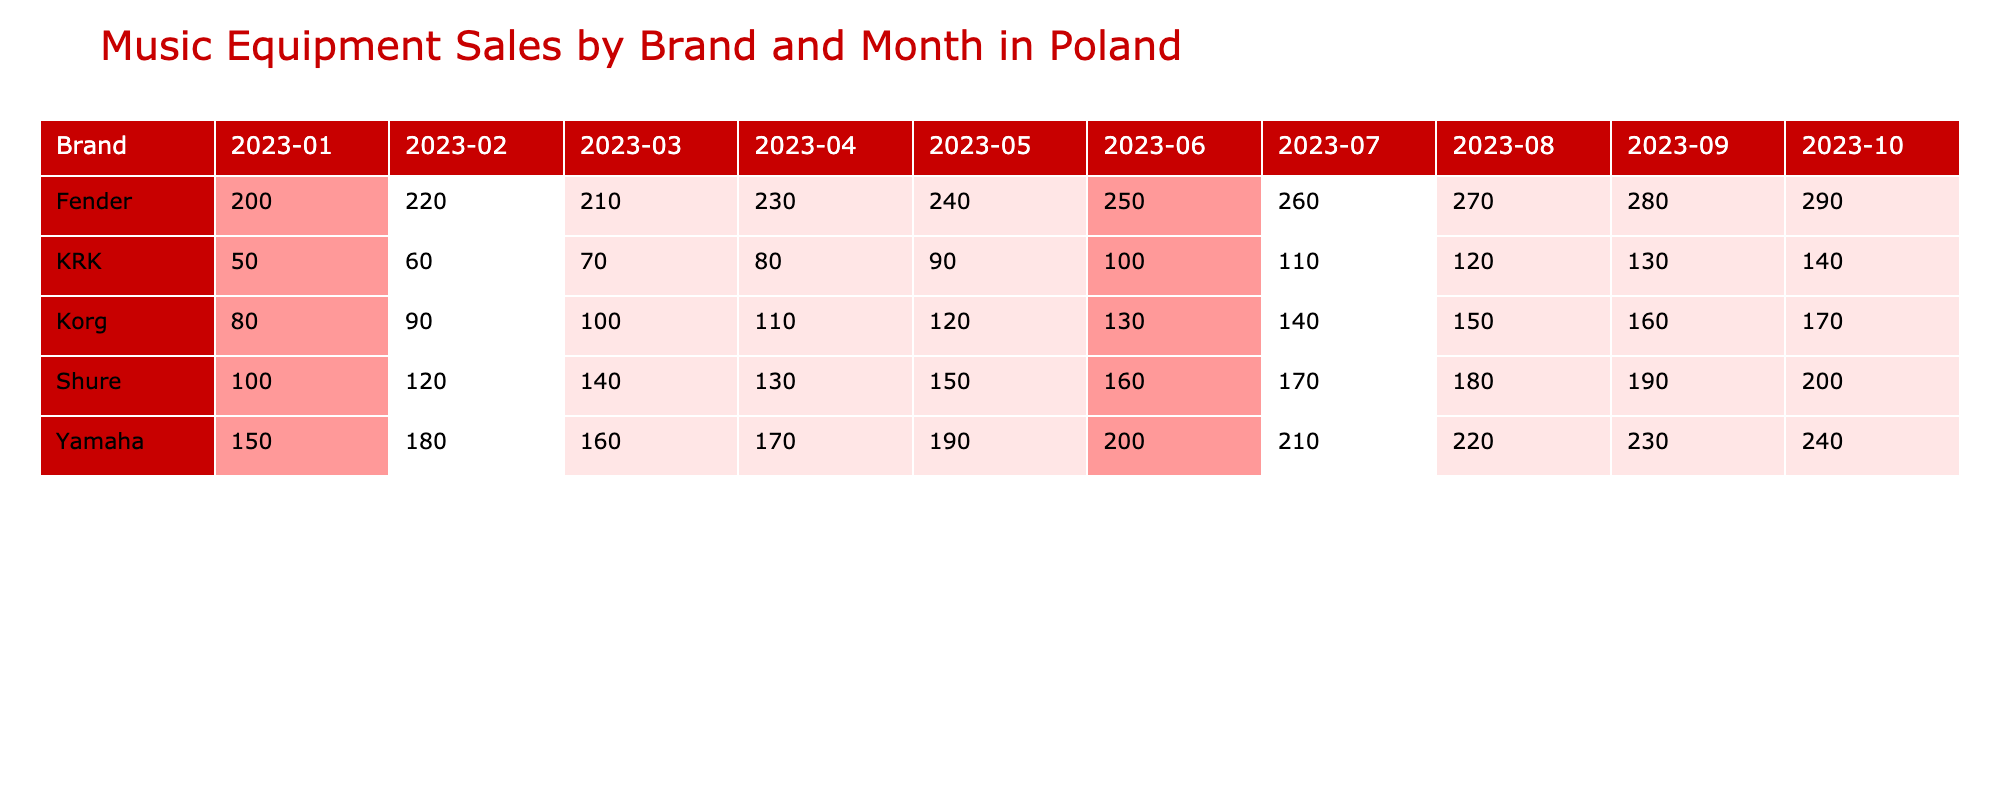What brand had the highest sales in June 2023? In June 2023, Yamaha, Fender, Shure, KRK, and Korg had sales of 200, 250, 160, 100, and 130 units respectively. Among these, Fender had the highest sales at 250 units.
Answer: Fender What were the total sales for Shure microphones from January to April 2023? The sales for Shure microphones from January to April are as follows: January - 100, February - 120, March - 140, April - 130. Adding these gives 100 + 120 + 140 + 130 = 490 units.
Answer: 490 units Did Korg synthesizers sell more in September 2023 than in August 2023? In August 2023, Korg sold 150 units and in September 2023, Korg sold 160 units. Since 160 is greater than 150, Korg sold more in September.
Answer: Yes What is the average monthly sales of guitars for Yamaha from January to October 2023? Adding the sales of Yamaha guitars from each month: 150 + 180 + 160 + 170 + 190 + 200 + 210 + 220 + 230 + 240 = 2000. This total is divided by the 10 months, yielding an average of 2000 / 10 = 200.
Answer: 200 Which brand had the lowest sales for monitors in March 2023? In March 2023, the sales for monitors were: KRK - 70 units. Since there is only one entry for monitors, KRK had the lowest sales.
Answer: KRK What was the difference in sales units between the best-selling and worst-selling brand for guitars in October 2023? In October 2023, Fender sold 290 guitars, while Yamaha sold 240 guitars. The difference is 290 - 240 = 50 units.
Answer: 50 units How did the sales of Fender guitars change over the months from January to October 2023? Fender guitars sold 200 in January, increasing each month to 290 in October, showing a steady upward trend with an increase of 90 units over 10 months.
Answer: Steadily increased Which brand consistently had increasing sales each month for synthesizers? Korg synthesizers had sales of 80 in January, increasing to 170 in October, showing a consistent increase each month.
Answer: Korg What was the total sales for KRK monitors from January to September 2023? The sales for KRK monitors were: January - 50, February - 60, March - 70, April - 80, May - 90, June - 100, July - 110, August - 120, September - 130. Adding these gives a total of 50 + 60 + 70 + 80 + 90 + 100 + 110 + 120 + 130 = 820.
Answer: 820 units Which month had the highest sales for guitars overall, and what was the total? Total guitar sales for each month are: January - 350, February - 400, March - 370, April - 400, May - 430, June - 450, July - 470, August - 490, September - 510, October - 530. October had the highest sales of 530.
Answer: October, 530 units 